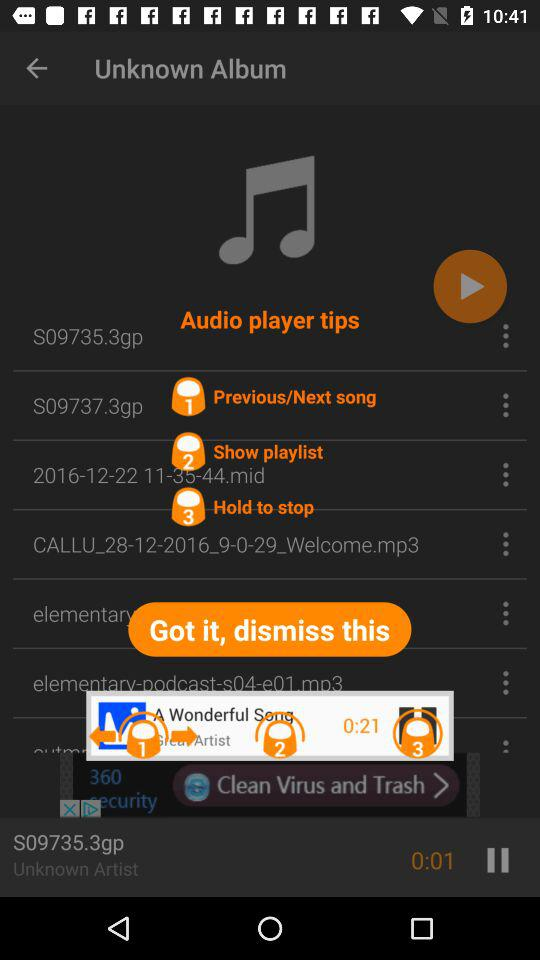What is the 3rd tip of the audio player? The 3rd tip is "Hold to stop". 